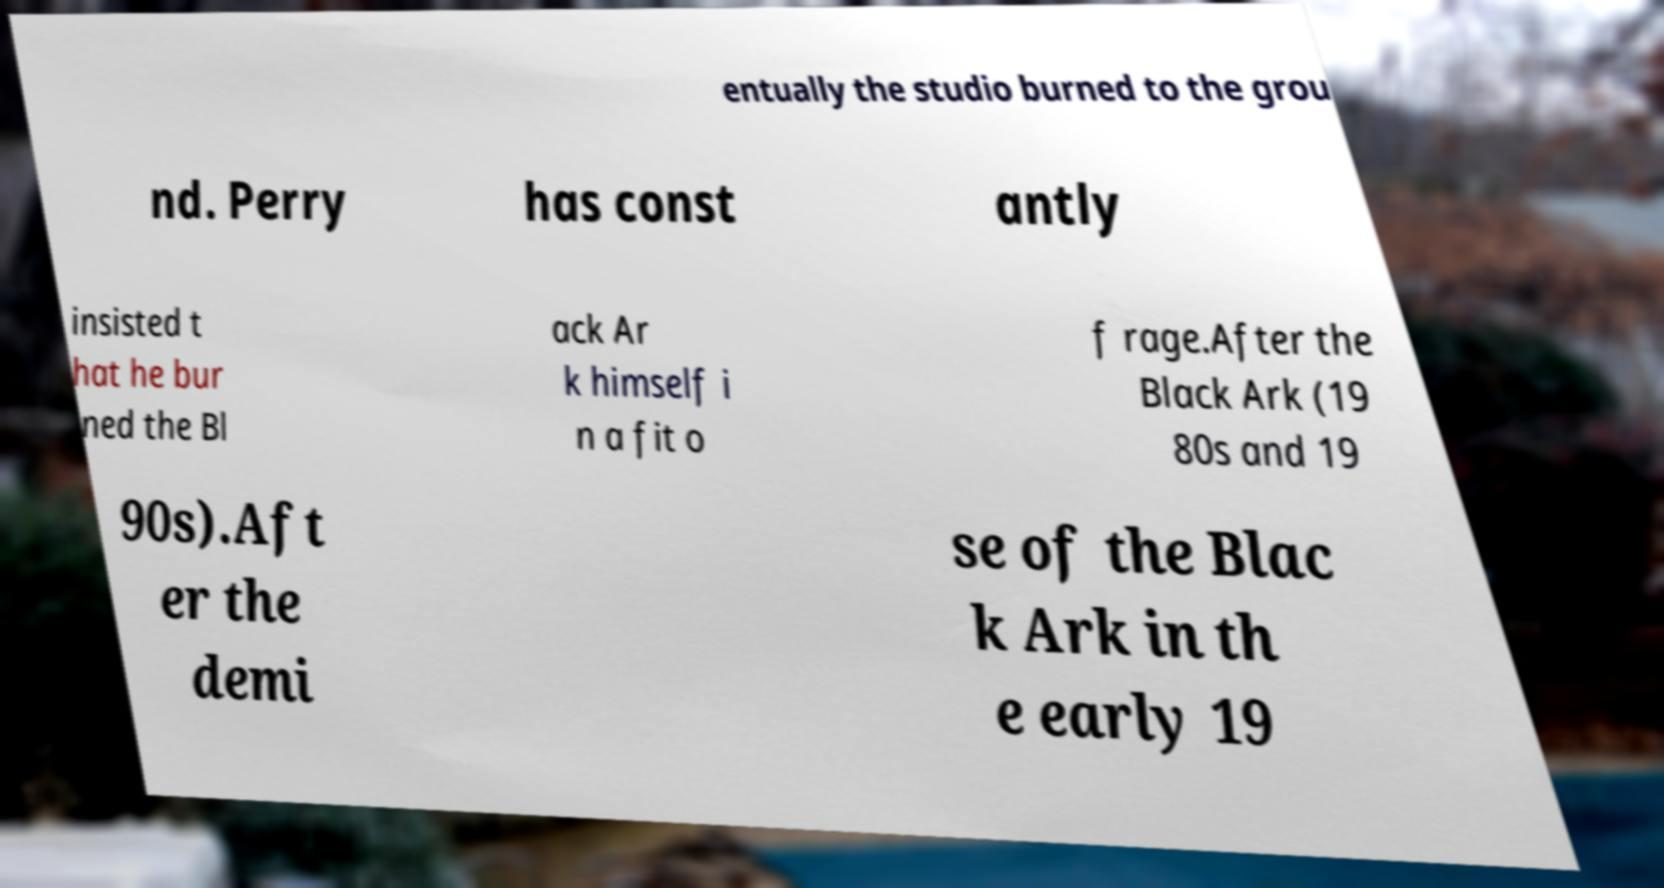Could you assist in decoding the text presented in this image and type it out clearly? entually the studio burned to the grou nd. Perry has const antly insisted t hat he bur ned the Bl ack Ar k himself i n a fit o f rage.After the Black Ark (19 80s and 19 90s).Aft er the demi se of the Blac k Ark in th e early 19 